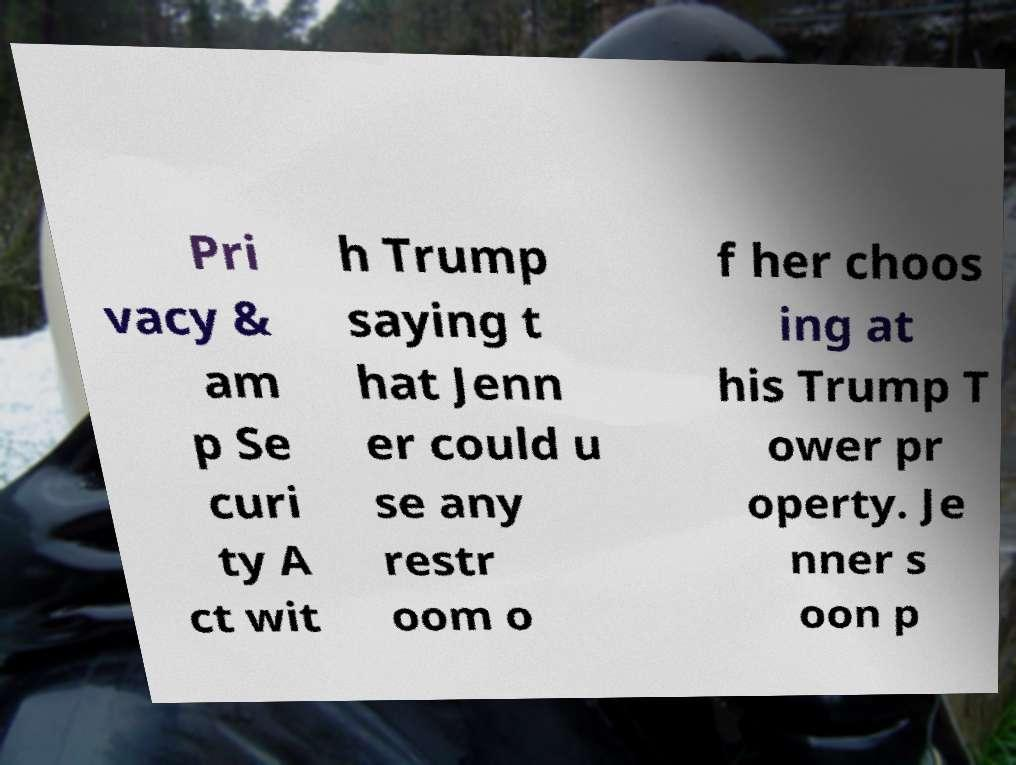For documentation purposes, I need the text within this image transcribed. Could you provide that? Pri vacy & am p Se curi ty A ct wit h Trump saying t hat Jenn er could u se any restr oom o f her choos ing at his Trump T ower pr operty. Je nner s oon p 